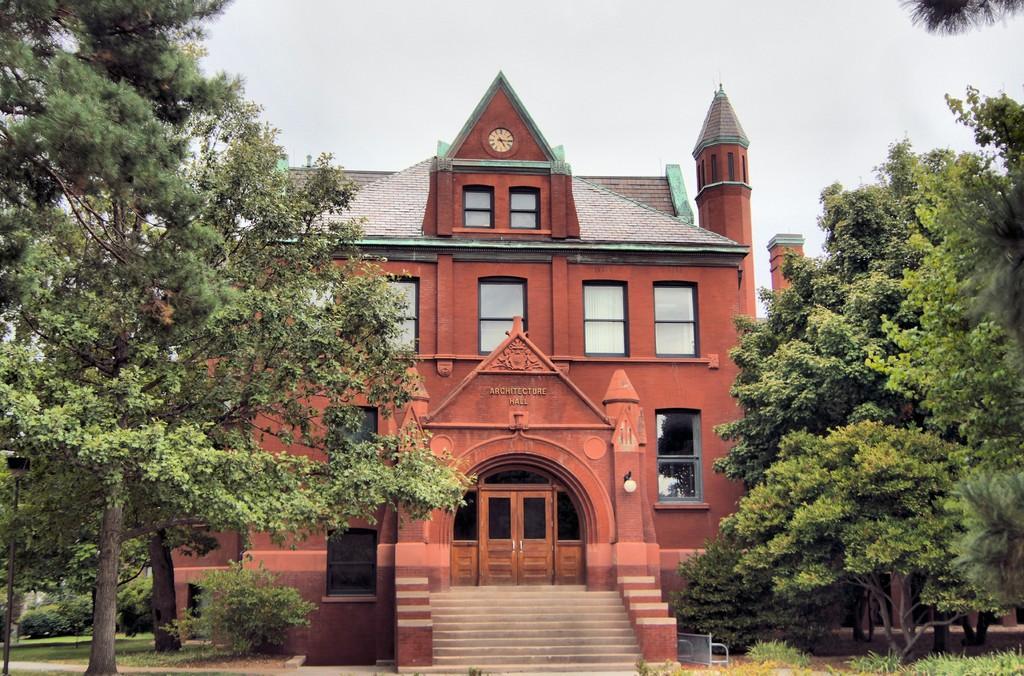In one or two sentences, can you explain what this image depicts? There are trees on both the sides of the image, there is a house structure, plants and the sky in the background area. 